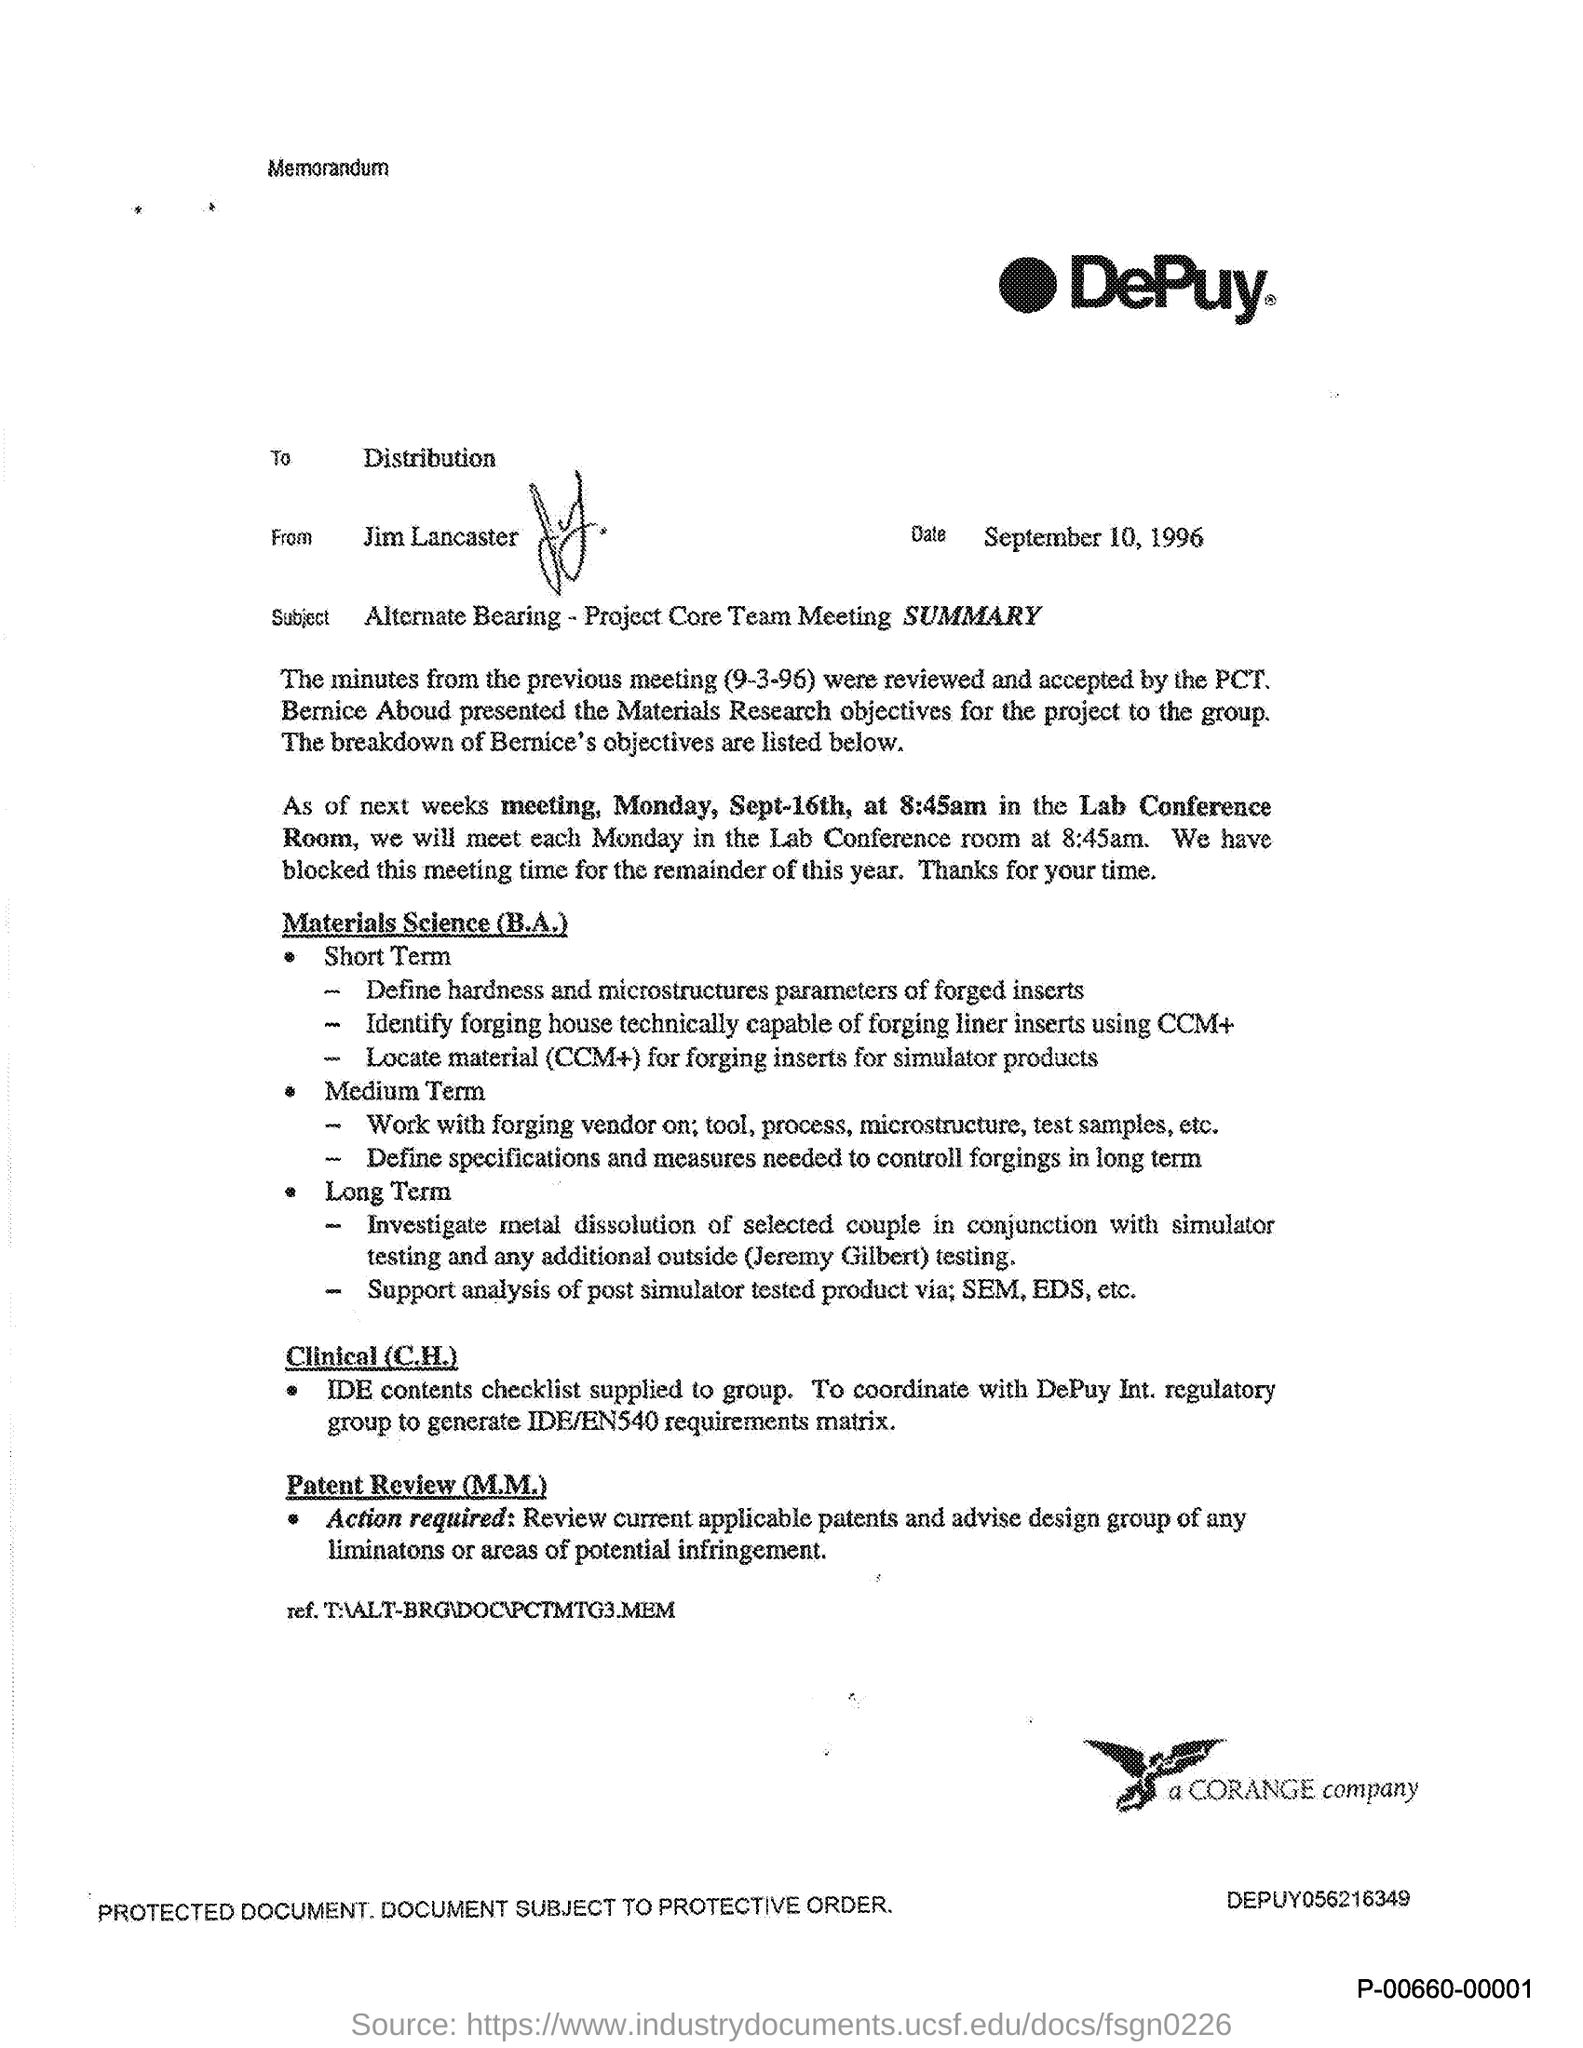Give some essential details in this illustration. The document is from Jim Lancaster. The memorandum is addressed to a group of individuals, with the word "distribution" included in the title. The location of the meeting scheduled for Sep-16th is the Lab Conference Room. This document is dated September 10, 1996. 